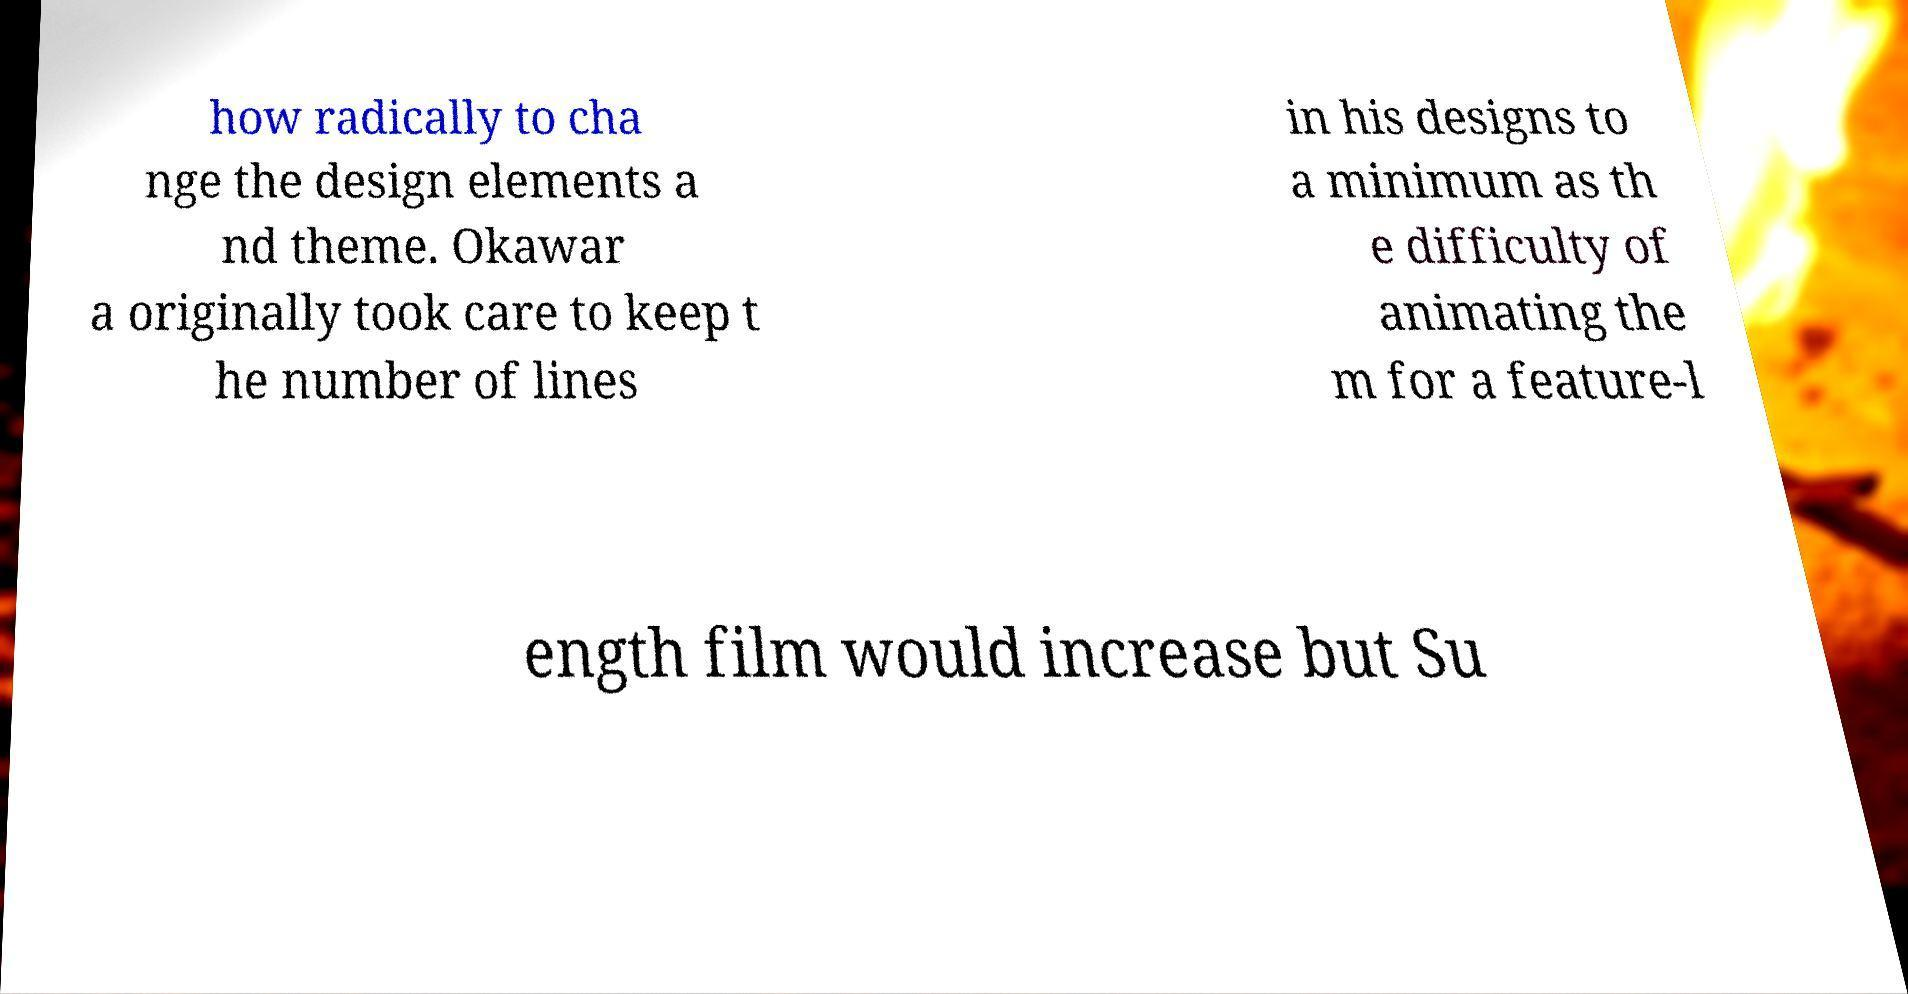I need the written content from this picture converted into text. Can you do that? how radically to cha nge the design elements a nd theme. Okawar a originally took care to keep t he number of lines in his designs to a minimum as th e difficulty of animating the m for a feature-l ength film would increase but Su 